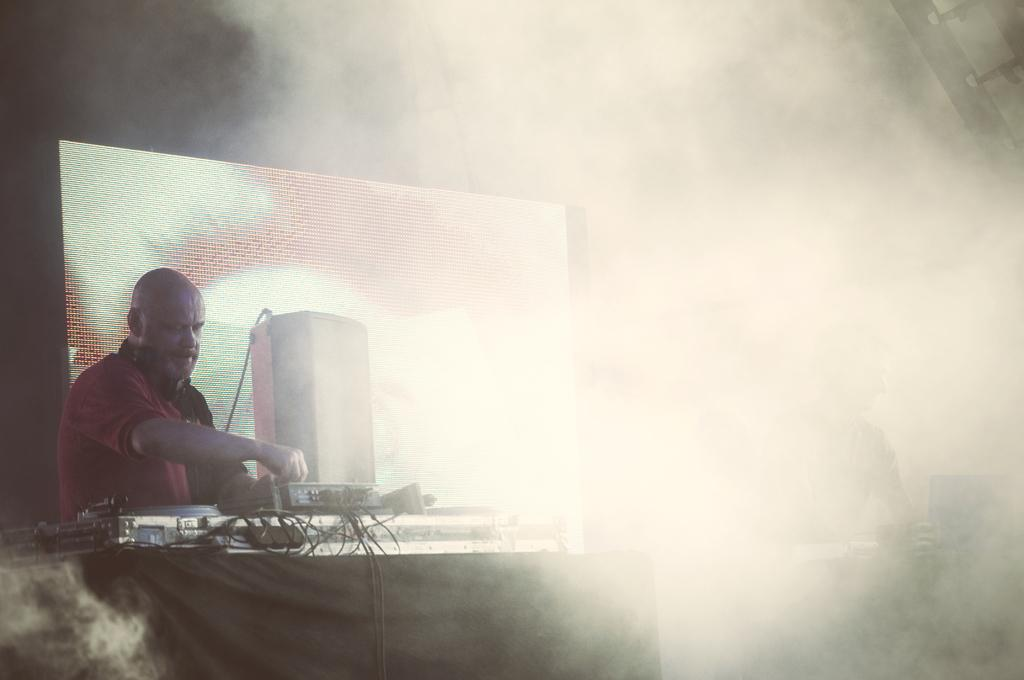What objects are located at the bottom of the image? There are tables at the bottom of the image. What is placed on the tables? There are musical devices on the tables. Who is present near the tables? Two persons are standing behind the tables. What can be seen in the background of the image? There is a screen visible in the background, and fog is present in the background. Can you tell me where the boy is swinging in the image? There is no boy or swing present in the image. What type of tin is visible on the tables? There is no tin visible on the tables; only musical devices are present. 